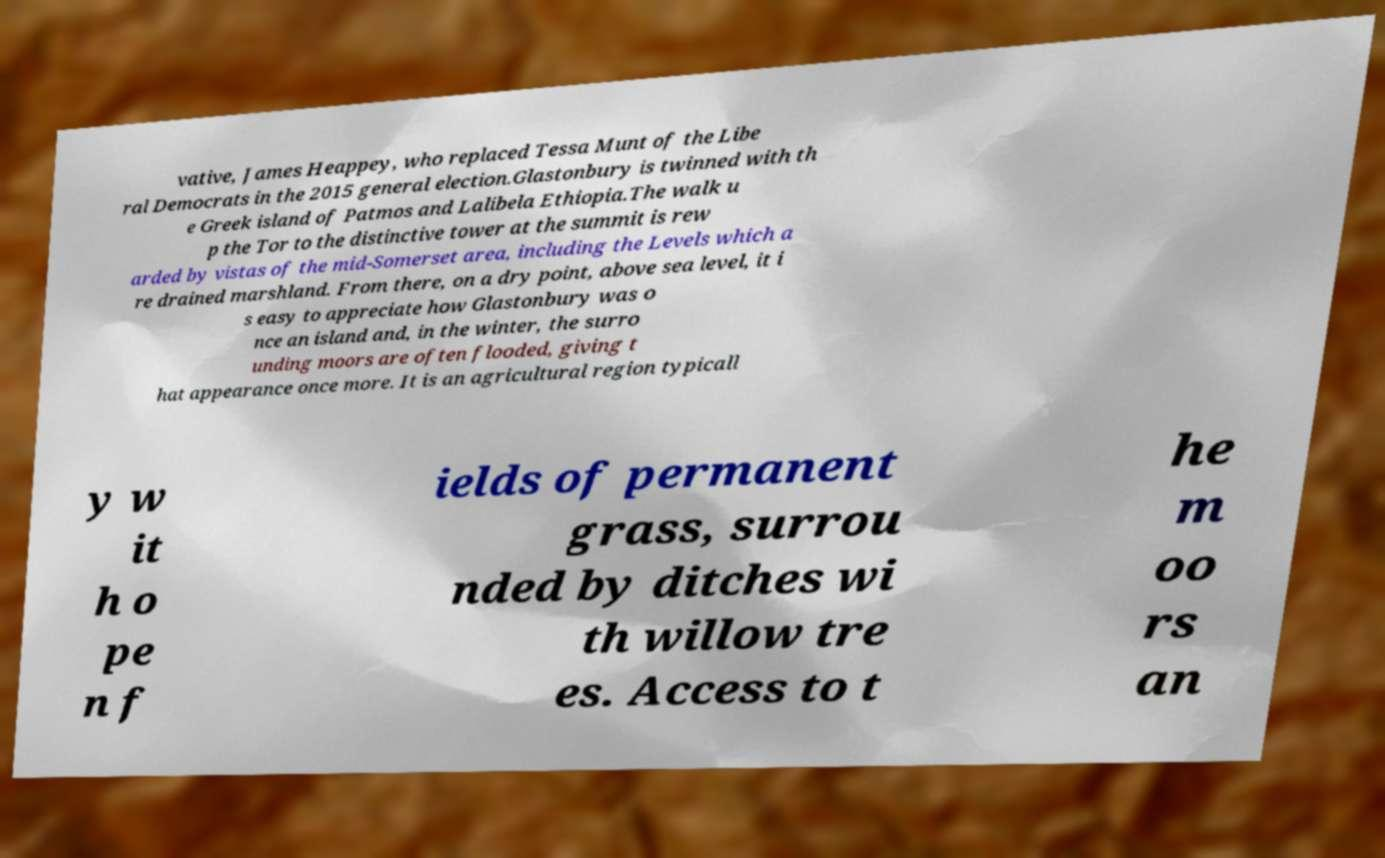Please read and relay the text visible in this image. What does it say? vative, James Heappey, who replaced Tessa Munt of the Libe ral Democrats in the 2015 general election.Glastonbury is twinned with th e Greek island of Patmos and Lalibela Ethiopia.The walk u p the Tor to the distinctive tower at the summit is rew arded by vistas of the mid-Somerset area, including the Levels which a re drained marshland. From there, on a dry point, above sea level, it i s easy to appreciate how Glastonbury was o nce an island and, in the winter, the surro unding moors are often flooded, giving t hat appearance once more. It is an agricultural region typicall y w it h o pe n f ields of permanent grass, surrou nded by ditches wi th willow tre es. Access to t he m oo rs an 